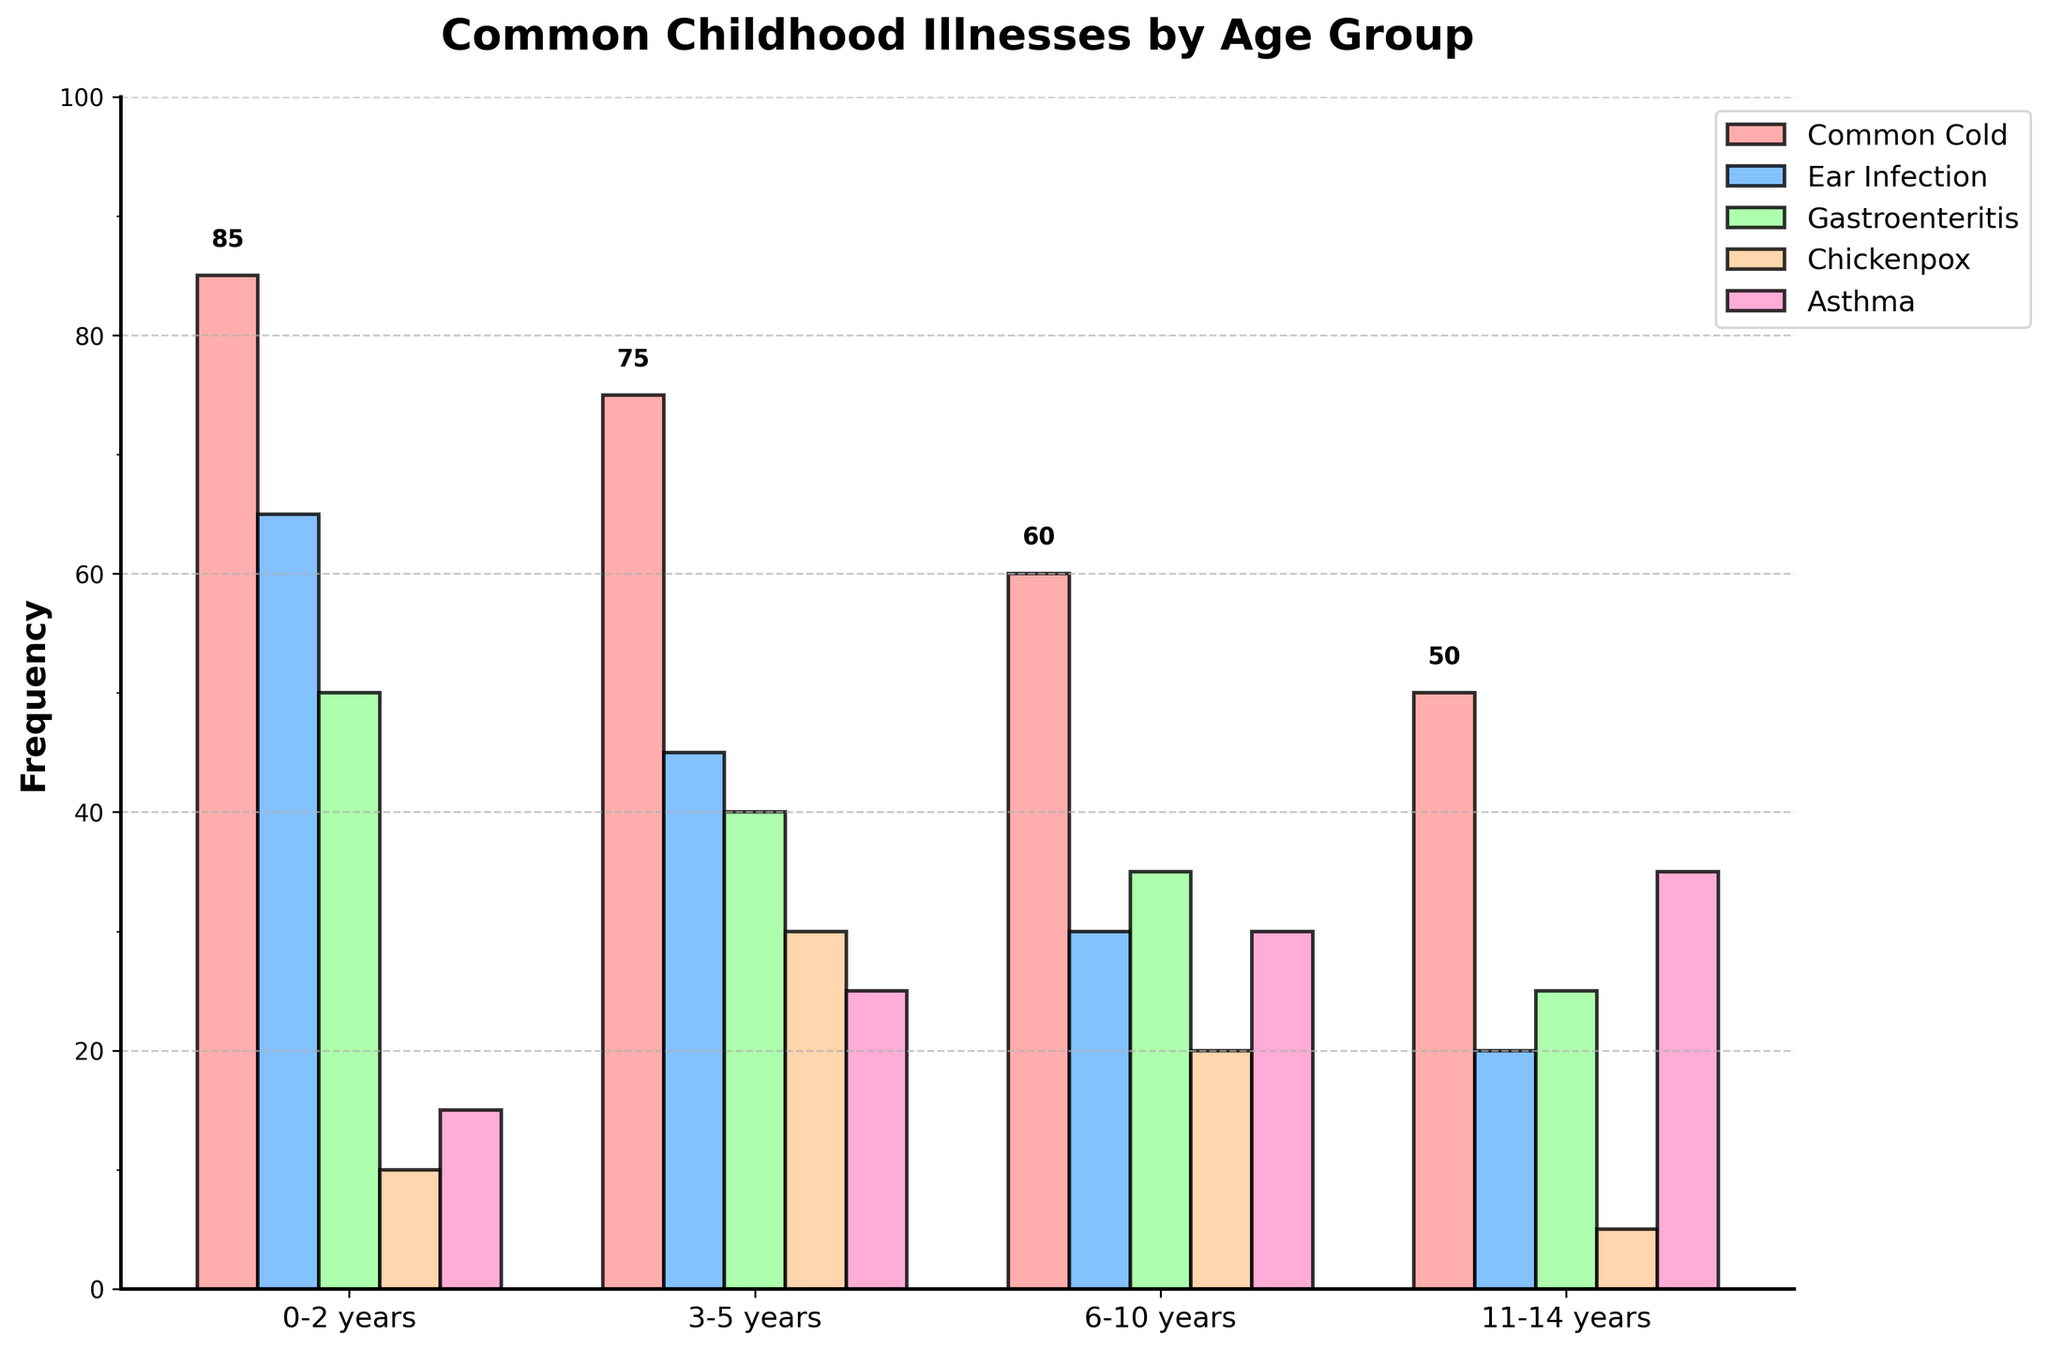What is the most common illness for children aged 0-2 years? Looking at the bars for the age group 0-2 years, the tallest bar represents 'Common Cold' which has the highest frequency.
Answer: Common Cold Which age group has the highest frequency of Gastroenteritis? Comparing the heights of the bars labeled 'Gastroenteritis' across age groups, the 0-2 years group has the tallest bar. This indicates the highest frequency.
Answer: 0-2 years Between children aged 6-10 years and 11-14 years, which age group has a higher frequency of Asthma? By observing the height of the 'Asthma' bar for 6-10 years and 11-14 years, it's clear that the 11-14 years bar is taller, showing a higher frequency.
Answer: 11-14 years What is the combined frequency of Chickenpox and Common Cold for children aged 3-5 years? For the age group 3-5 years, the bar heights give us 30 for Chickenpox and 75 for Common Cold. Summing these values: 30 + 75 = 105.
Answer: 105 Is the frequency of Ear Infection in 0-2 years greater than the frequency of Asthma in 3-5 years? The Ear Infection bar for 0-2 years has a height of 65, and the Asthma bar for 3-5 years has a height of 25. Since 65 is greater than 25, the answer is yes.
Answer: Yes What illness shows a decreasing frequency trend as children age from 0-2 years to 11-14 years? Observing the trend for each illness across the age groups, 'Common Cold' shows a clear decreasing trend: 85 to 75 to 60 to 50.
Answer: Common Cold Which illness has nearly the same frequency in both 3-5 years and 6-10 years age groups? By comparing the bar heights, 'Gastroenteritis' has frequencies of 40 and 35 for 3-5 years and 6-10 years respectively, which are very close.
Answer: Gastroenteritis What is the total frequency of illnesses for the 11-14 years age group? Summing the heights of all the bars for the 11-14 years group: 50 (Common Cold) + 20 (Ear Infection) + 25 (Gastroenteritis) + 5 (Chickenpox) + 35 (Asthma) = 135.
Answer: 135 How many more cases of Asthma are there in the 11-14 years group compared to the 0-2 years group? The bar heights for Asthma in 11-14 years and 0-2 years are 35 and 15 respectively. The difference is calculated as 35 - 15 = 20.
Answer: 20 